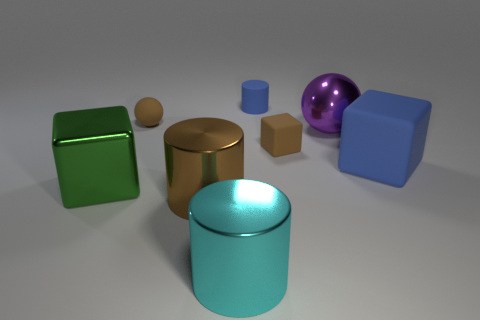Do the green thing and the big purple metallic thing have the same shape?
Offer a very short reply. No. Are there any brown metallic cylinders behind the big cyan object?
Keep it short and to the point. Yes. What number of things are either brown matte spheres or big yellow metal balls?
Ensure brevity in your answer.  1. What number of other things are the same size as the purple metallic sphere?
Ensure brevity in your answer.  4. How many objects are in front of the big purple shiny object and on the left side of the tiny rubber cube?
Your response must be concise. 3. Do the metallic thing that is behind the big green metal block and the rubber block that is on the right side of the tiny cube have the same size?
Keep it short and to the point. Yes. How big is the matte block that is left of the purple ball?
Ensure brevity in your answer.  Small. How many things are blue cylinders that are behind the small brown cube or objects left of the cyan thing?
Offer a terse response. 4. Is there any other thing that has the same color as the big matte thing?
Your answer should be compact. Yes. Are there the same number of blue matte objects in front of the tiny matte ball and cyan metal objects on the right side of the large green block?
Keep it short and to the point. Yes. 